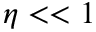Convert formula to latex. <formula><loc_0><loc_0><loc_500><loc_500>\eta < < 1</formula> 